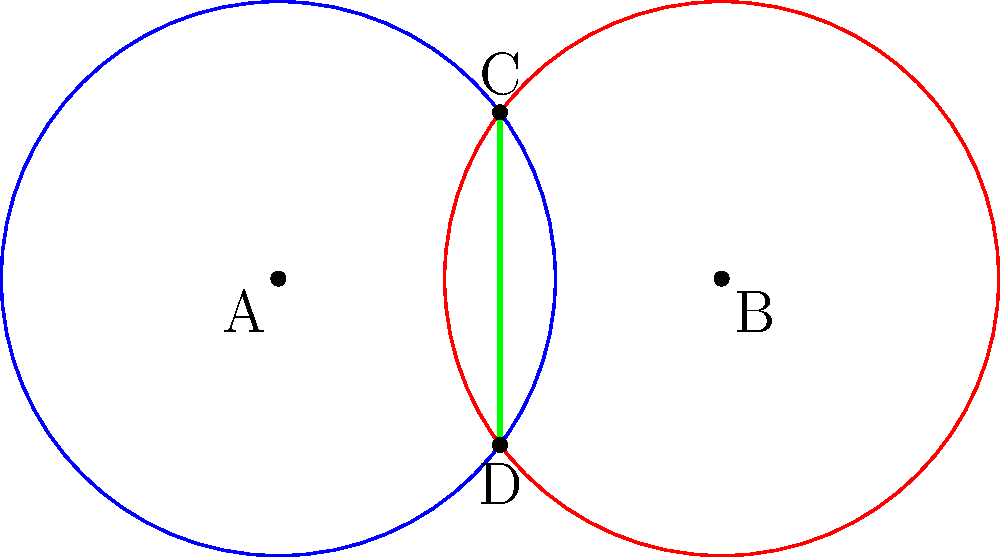In the diagram above, two circles of radius 2.5 units intersect to form a vesica piscis shape, reminiscent of ancient seals found in archaeological digs. The centers of the circles are 4 units apart. If points C and D represent the intersections of the circles, what is the area of the vesica piscis (the overlapping region ACBD)? To find the area of the vesica piscis, we can follow these steps:

1) First, we need to find the angle θ at the center of each circle subtended by the chord CD.
   Using the formula: $\cos(\frac{\theta}{2}) = \frac{d}{2r}$, where d is the distance between centers and r is the radius.
   
   $\cos(\frac{\theta}{2}) = \frac{4}{2(2.5)} = \frac{4}{5}$
   
   $\theta = 2 \arccos(\frac{4}{5}) \approx 1.2870$ radians

2) The area of the vesica piscis is twice the area of the circular sector minus the area of the triangle:

   Area = $2(\frac{1}{2}r^2\theta - \frac{1}{2}r^2\sin\theta)$
   
3) Substituting the values:

   Area = $2(\frac{1}{2}(2.5)^2(1.2870) - \frac{1}{2}(2.5)^2\sin(1.2870))$
        = $2(4.0218 - 2.4000)$
        = $2(1.6218)$
        = $3.2436$ square units

Therefore, the area of the vesica piscis is approximately 3.2436 square units.
Answer: 3.2436 square units 